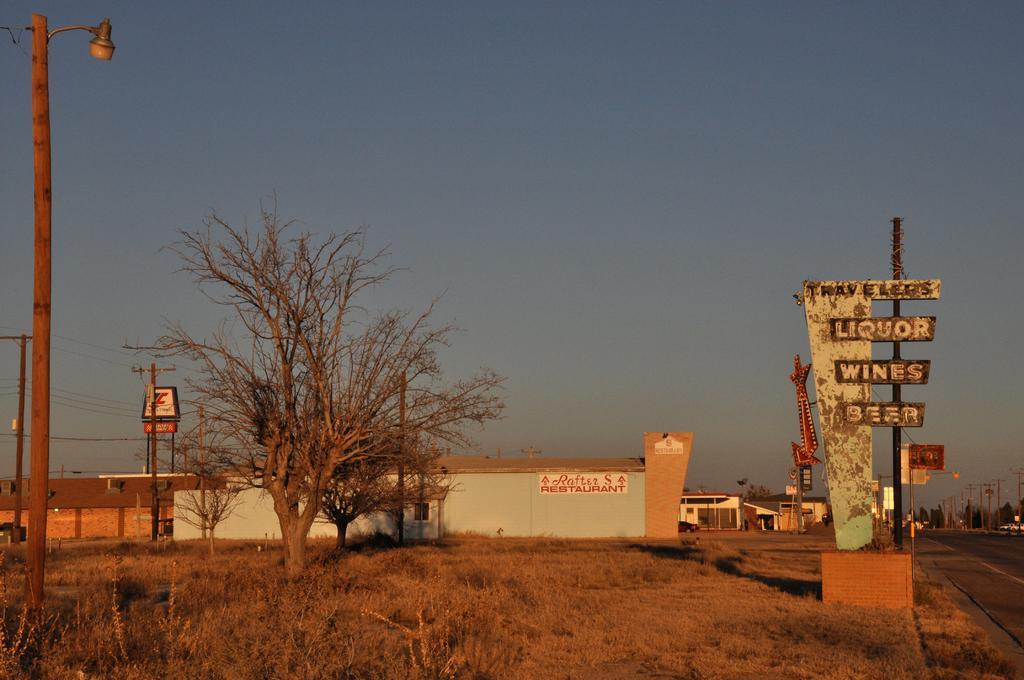Describe this image in one or two sentences. Here we can see poles, trees, boards, and houses. This is a road. In the background there is sky. 